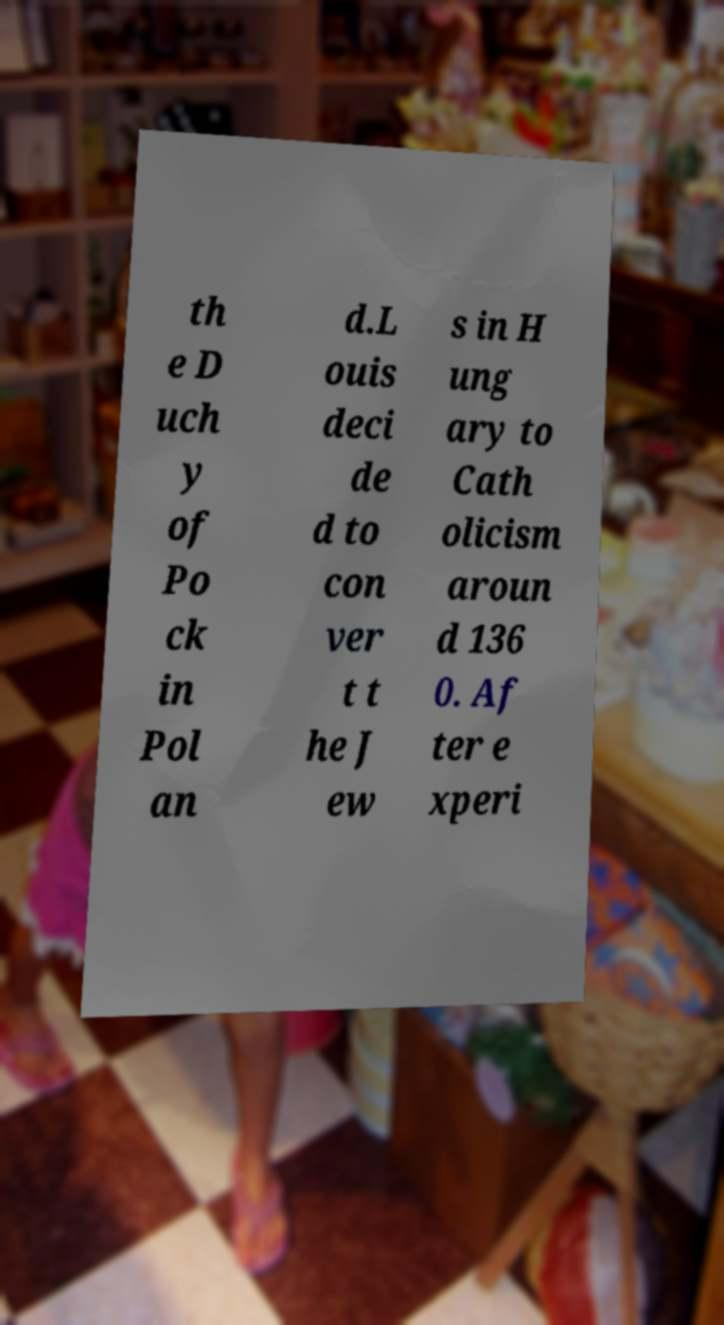Could you extract and type out the text from this image? th e D uch y of Po ck in Pol an d.L ouis deci de d to con ver t t he J ew s in H ung ary to Cath olicism aroun d 136 0. Af ter e xperi 